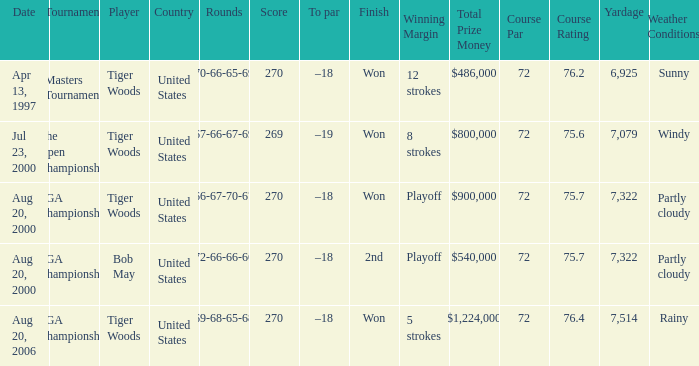What players finished 2nd? Bob May. 